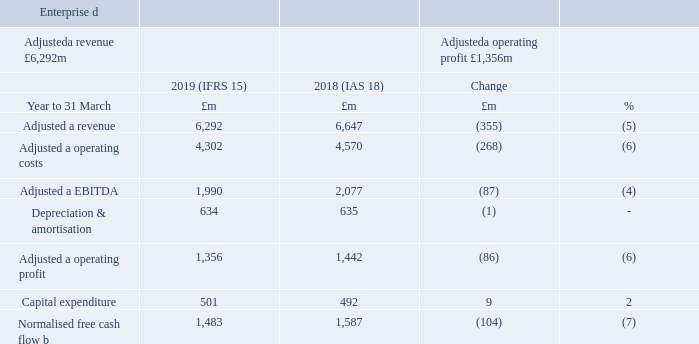The UK and Ireland business-to-business market remains challenging. The main headwind we face is the decline in traditional calls and lines where we have a relatively high market share. The IP Voice market is significantly more fragmented, with a large number of providers, and we are focused on expanding our share in this growing market.
The mobile market remains competitive and we continue to see pressure on pricing. While overall growth in the broadband market is limited, we are seeing good demand for our premium products such as fibre and 4G Assure. Newer areas such as the Internet of Things, Cloud, SDWAN and security remain good opportunities for us over the longer term.
Adjusted a revenue decreased 5% for the year mainly due to the ongoing decline of fixed voice revenue. We continue to see a steeper than expected reduction in calls per fixed line as usage moves to mobile and IP. We continue to sell less low margin equipment and also experienced ongoing declines in some of our other legacy products such as private circuits. This was partially offset by growth in IP, Mobile and Networking. We’re also continuing to see encouraging growth in messaging volumes in Ventures.
Adjusted a operating costs reduced 6%, helped by labour cost efficiencies from our cost transformation programmes. Adjusteda EBITDA decreased 4%, with our lower cost base more than offset by the reduction in revenue.
Capital expenditure increased 2% and normalised free cash flowb decreased 7%, reflecting the reduction in EBITDA and the higher capital expenditure.
The Retail order intake decreased 15% to £2.9bn for the year due to the signing of a large contract in Republic of Ireland in the prior year. The Wholesale order intake declined 22% to £1.0bn after 2017/18 benefitted from a number of large deals, including the timing of some contract renewals.
a Adjusted measures exclude specific items, as explained in the Additional Information on page 185. b Free cash flow after net interest paid, before pension deficit payments (including the cash tax benefit of pension deficit payments) and specific items. d Enterprise comparatives have been re-presented to reflect the bringing together of our Business and Public Sector and Wholesale and Ventures units into a single Enterprise unit, as well as the transfer of Northern Ireland Networks from Enterprise to Openreach.
What is the main challenge faced by the company? The main headwind we face is the decline in traditional calls and lines where we have a relatively high market share. What is the decrease in adjusted revenue? 5%. What caused the decrease in retail order? Due to the signing of a large contract in republic of ireland in the prior year. What was the percentage change in the Adjusted a revenue from 2018 to 2019?
Answer scale should be: percent. 6,292 / 6,647 - 1
Answer: -5.34. What is the average Adjusted a operating costs for 2018 and 2019?
Answer scale should be: million. (4,302 + 4,570) / 2
Answer: 4436. What is the EBITDA margin in 2019? 1,990 / 6,292
Answer: 0.32. 